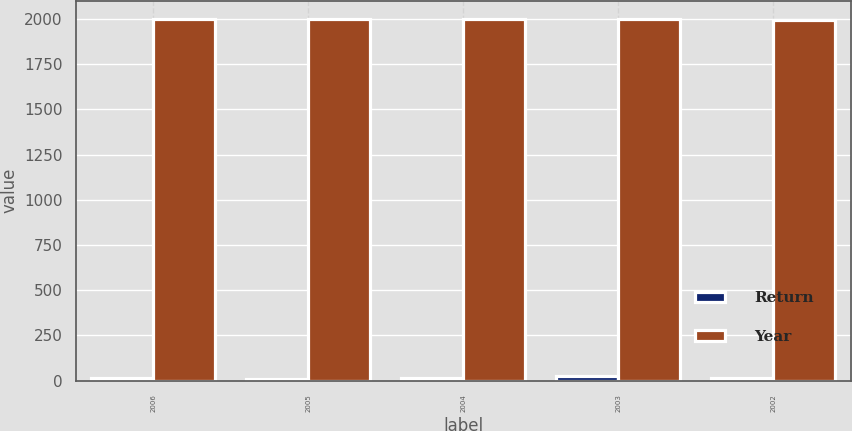<chart> <loc_0><loc_0><loc_500><loc_500><stacked_bar_chart><ecel><fcel>2006<fcel>2005<fcel>2004<fcel>2003<fcel>2002<nl><fcel>Return<fcel>14.9<fcel>9.8<fcel>12.6<fcel>25<fcel>13.4<nl><fcel>Year<fcel>2001<fcel>2000<fcel>1999<fcel>1998<fcel>1997<nl></chart> 